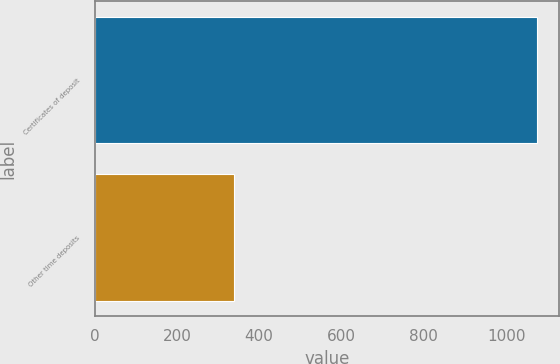<chart> <loc_0><loc_0><loc_500><loc_500><bar_chart><fcel>Certificates of deposit<fcel>Other time deposits<nl><fcel>1075<fcel>338<nl></chart> 